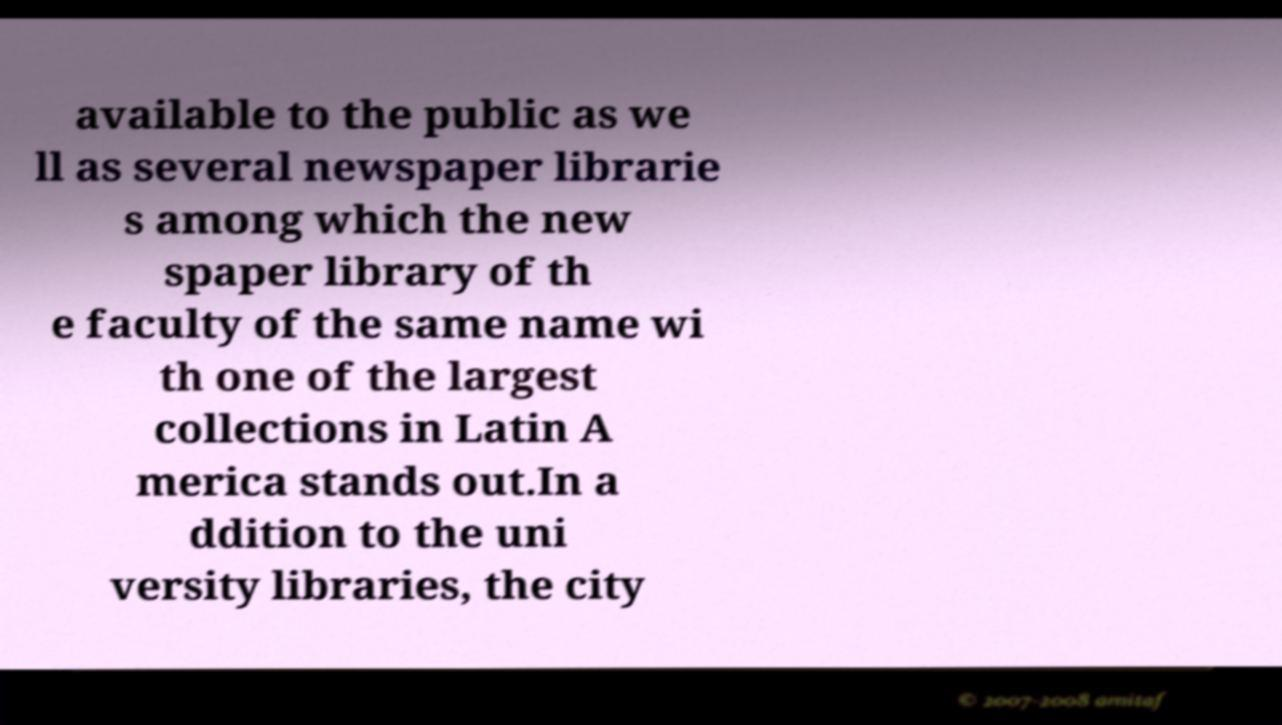Please identify and transcribe the text found in this image. available to the public as we ll as several newspaper librarie s among which the new spaper library of th e faculty of the same name wi th one of the largest collections in Latin A merica stands out.In a ddition to the uni versity libraries, the city 